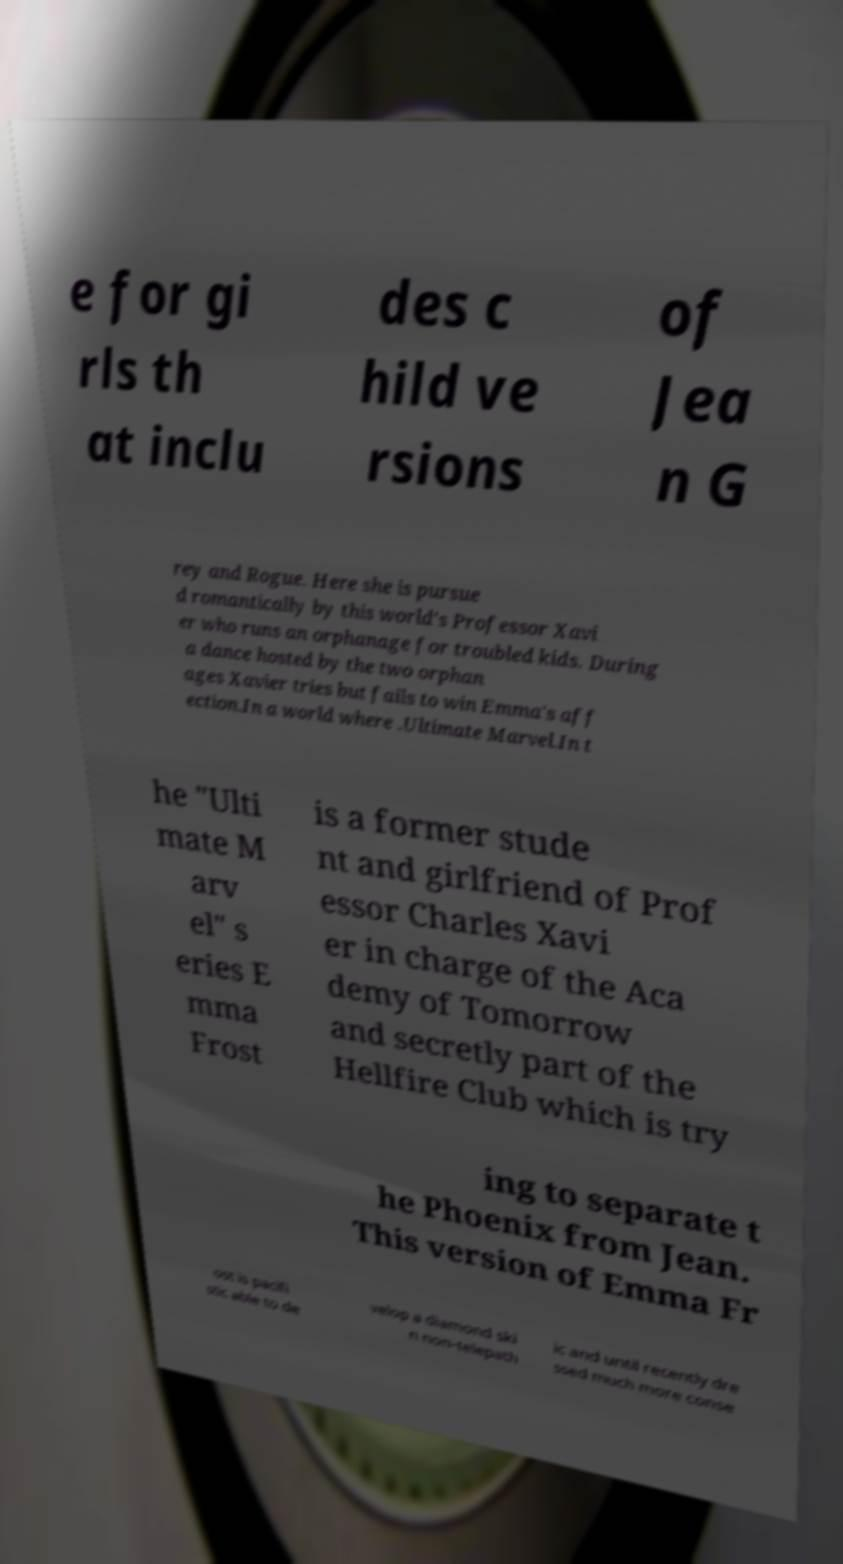Could you assist in decoding the text presented in this image and type it out clearly? e for gi rls th at inclu des c hild ve rsions of Jea n G rey and Rogue. Here she is pursue d romantically by this world's Professor Xavi er who runs an orphanage for troubled kids. During a dance hosted by the two orphan ages Xavier tries but fails to win Emma's aff ection.In a world where .Ultimate Marvel.In t he "Ulti mate M arv el" s eries E mma Frost is a former stude nt and girlfriend of Prof essor Charles Xavi er in charge of the Aca demy of Tomorrow and secretly part of the Hellfire Club which is try ing to separate t he Phoenix from Jean. This version of Emma Fr ost is pacifi stic able to de velop a diamond ski n non-telepath ic and until recently dre ssed much more conse 